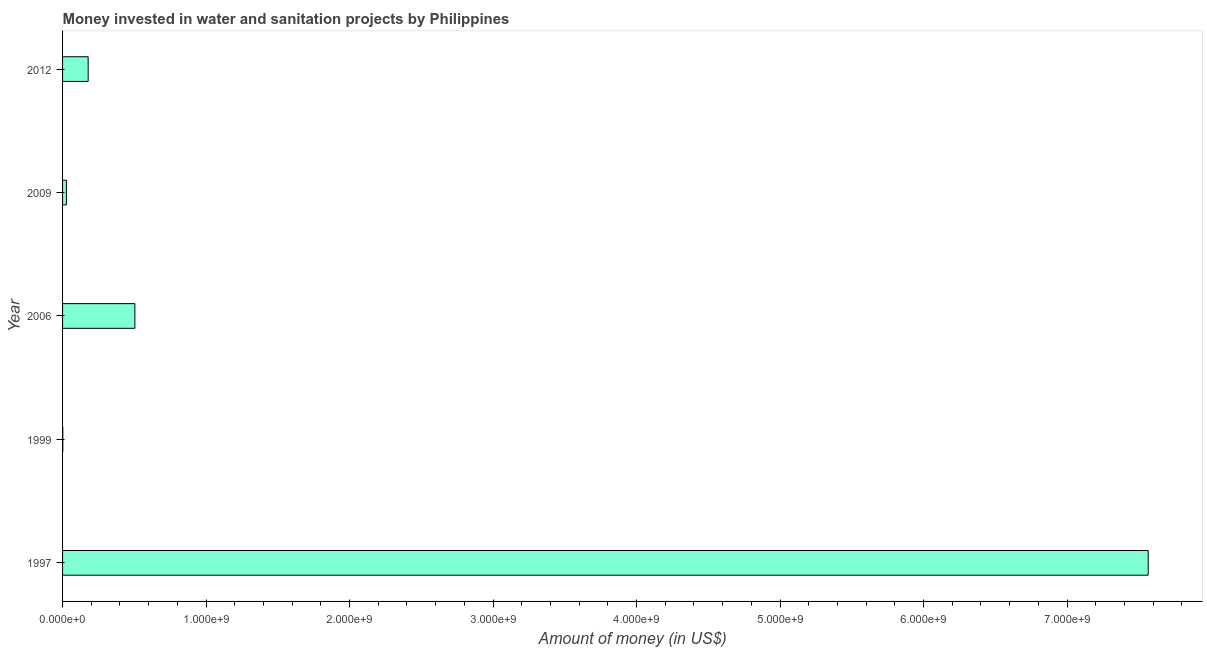Does the graph contain grids?
Offer a terse response. No. What is the title of the graph?
Offer a terse response. Money invested in water and sanitation projects by Philippines. What is the label or title of the X-axis?
Offer a terse response. Amount of money (in US$). What is the investment in 2009?
Provide a succinct answer. 2.66e+07. Across all years, what is the maximum investment?
Your answer should be compact. 7.57e+09. Across all years, what is the minimum investment?
Your answer should be compact. 1.60e+06. In which year was the investment maximum?
Your answer should be very brief. 1997. What is the sum of the investment?
Provide a succinct answer. 8.28e+09. What is the difference between the investment in 2009 and 2012?
Ensure brevity in your answer.  -1.52e+08. What is the average investment per year?
Keep it short and to the point. 1.66e+09. What is the median investment?
Offer a very short reply. 1.78e+08. In how many years, is the investment greater than 400000000 US$?
Ensure brevity in your answer.  2. What is the ratio of the investment in 1997 to that in 2012?
Make the answer very short. 42.43. Is the difference between the investment in 2006 and 2012 greater than the difference between any two years?
Your answer should be very brief. No. What is the difference between the highest and the second highest investment?
Your response must be concise. 7.06e+09. What is the difference between the highest and the lowest investment?
Your answer should be very brief. 7.56e+09. In how many years, is the investment greater than the average investment taken over all years?
Offer a terse response. 1. What is the Amount of money (in US$) in 1997?
Offer a very short reply. 7.57e+09. What is the Amount of money (in US$) in 1999?
Your response must be concise. 1.60e+06. What is the Amount of money (in US$) of 2006?
Your answer should be very brief. 5.04e+08. What is the Amount of money (in US$) in 2009?
Provide a short and direct response. 2.66e+07. What is the Amount of money (in US$) of 2012?
Your answer should be very brief. 1.78e+08. What is the difference between the Amount of money (in US$) in 1997 and 1999?
Provide a succinct answer. 7.56e+09. What is the difference between the Amount of money (in US$) in 1997 and 2006?
Keep it short and to the point. 7.06e+09. What is the difference between the Amount of money (in US$) in 1997 and 2009?
Your answer should be very brief. 7.54e+09. What is the difference between the Amount of money (in US$) in 1997 and 2012?
Your response must be concise. 7.39e+09. What is the difference between the Amount of money (in US$) in 1999 and 2006?
Your answer should be compact. -5.02e+08. What is the difference between the Amount of money (in US$) in 1999 and 2009?
Provide a short and direct response. -2.50e+07. What is the difference between the Amount of money (in US$) in 1999 and 2012?
Offer a very short reply. -1.77e+08. What is the difference between the Amount of money (in US$) in 2006 and 2009?
Provide a short and direct response. 4.77e+08. What is the difference between the Amount of money (in US$) in 2006 and 2012?
Offer a terse response. 3.26e+08. What is the difference between the Amount of money (in US$) in 2009 and 2012?
Offer a very short reply. -1.52e+08. What is the ratio of the Amount of money (in US$) in 1997 to that in 1999?
Offer a very short reply. 4728.5. What is the ratio of the Amount of money (in US$) in 1997 to that in 2006?
Ensure brevity in your answer.  15.01. What is the ratio of the Amount of money (in US$) in 1997 to that in 2009?
Make the answer very short. 284.42. What is the ratio of the Amount of money (in US$) in 1997 to that in 2012?
Your answer should be compact. 42.43. What is the ratio of the Amount of money (in US$) in 1999 to that in 2006?
Provide a succinct answer. 0. What is the ratio of the Amount of money (in US$) in 1999 to that in 2012?
Make the answer very short. 0.01. What is the ratio of the Amount of money (in US$) in 2006 to that in 2009?
Keep it short and to the point. 18.94. What is the ratio of the Amount of money (in US$) in 2006 to that in 2012?
Keep it short and to the point. 2.83. What is the ratio of the Amount of money (in US$) in 2009 to that in 2012?
Give a very brief answer. 0.15. 